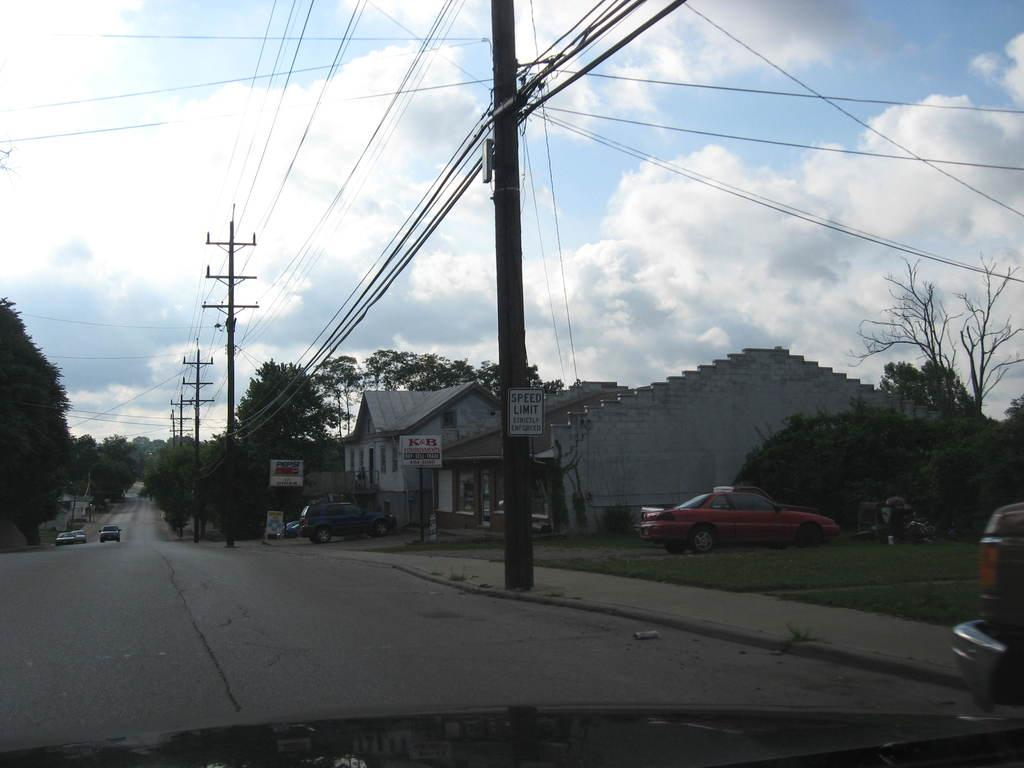What type of vehicles can be seen on the road in the image? There are cars on the road in the image. What structures are present in the image? There are poles, trees, houses, and a signboard in the image. What type of vegetation is visible in the image? There is grass in the image. What other objects can be seen in the image? There are name boards and wires in the image. What can be seen in the background of the image? The sky with clouds is visible in the background of the image. Can you tell me how many vessels are docked near the houses in the image? There are no vessels present in the image; it features cars on the road, poles, trees, houses, grass, a signboard, name boards, wires, and a sky with clouds in the background. Is there a birthday celebration happening in the image? There is no indication of a birthday celebration in the image. 